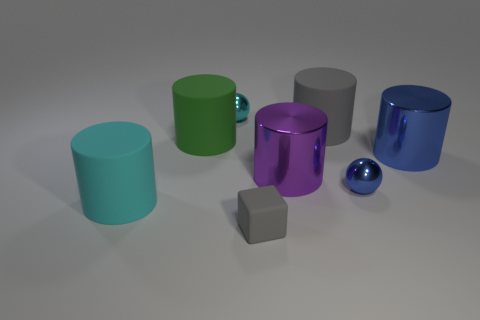Subtract all red cylinders. Subtract all gray blocks. How many cylinders are left? 5 Add 2 tiny red cylinders. How many objects exist? 10 Subtract all balls. How many objects are left? 6 Subtract all tiny blue metal objects. Subtract all small gray things. How many objects are left? 6 Add 5 blue shiny spheres. How many blue shiny spheres are left? 6 Add 8 big yellow shiny cylinders. How many big yellow shiny cylinders exist? 8 Subtract 1 blue balls. How many objects are left? 7 